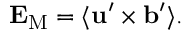Convert formula to latex. <formula><loc_0><loc_0><loc_500><loc_500>{ E } _ { M } = \langle { { u } ^ { \prime } \times { b } ^ { \prime } } \rangle .</formula> 